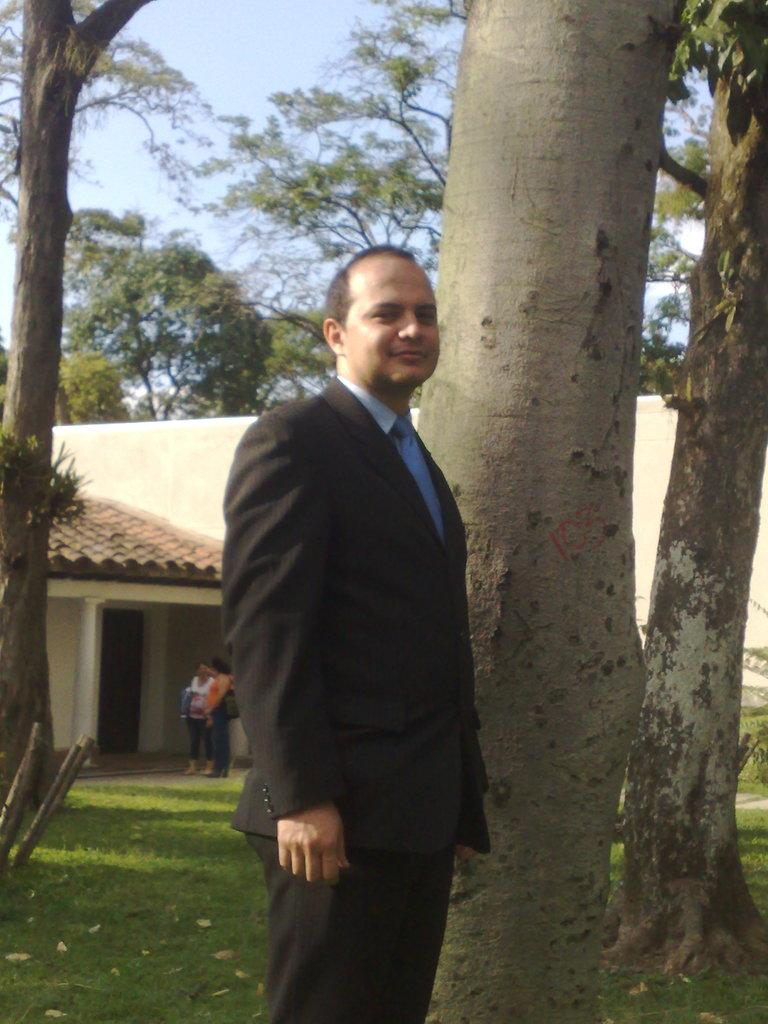Who or what can be seen in the image? There are people in the image. What type of natural environment is visible in the image? There are trees and grass in the image. What type of structure is present in the image? There is a building in the image. What part of the natural environment is visible in the image? The sky is visible in the image. What else can be seen in the image besides people, trees, grass, and the building? There are objects in the image. What type of cord is being used to hang the wall in the image? There is no wall or cord present in the image. What type of apparel is being worn by the people in the image? The provided facts do not mention any specific apparel worn by the people in the image. 